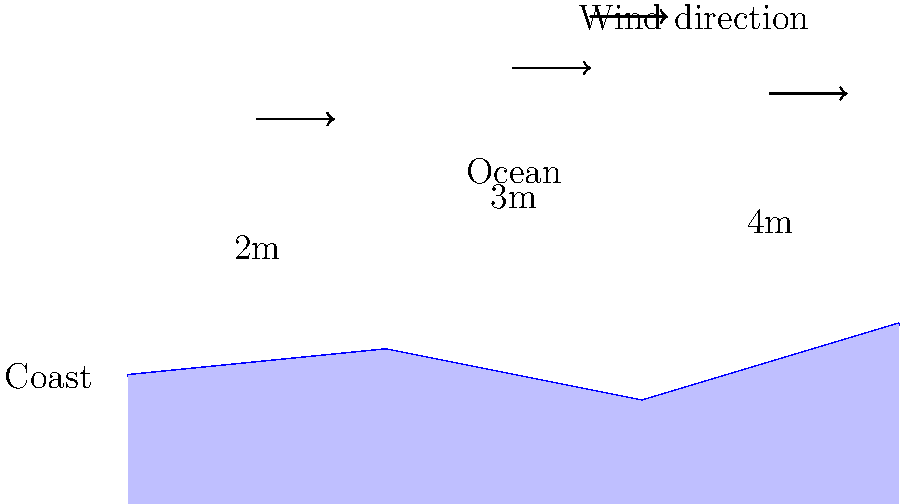Based on the coastal map showing wind directions and wave heights, which section of the coastline is likely to have the best surfing conditions for experienced surfers seeking larger waves? To determine the best surfing conditions for experienced surfers, we need to analyze the wind direction and wave heights shown on the map:

1. Wind direction: The arrows indicate that the wind is blowing from left to right (onshore wind) across the entire coastline.

2. Wave heights:
   - Left section: 2m waves
   - Middle section: 3m waves
   - Right section: 4m waves

3. Coastal shape:
   - The coastline has varying contours, which can affect wave formation.

4. Best conditions for experienced surfers:
   - Experienced surfers typically prefer larger waves.
   - The right section has the largest waves at 4m.
   - While onshore winds are generally less favorable for surfing, experienced surfers can still handle these conditions, especially with larger waves.

5. Conclusion:
   - The right section of the coastline offers the largest waves (4m).
   - Despite the onshore wind, this section is likely to provide the most challenging and exciting conditions for experienced surfers.

Therefore, the right section of the coastline is likely to have the best surfing conditions for experienced surfers seeking larger waves.
Answer: Right section 